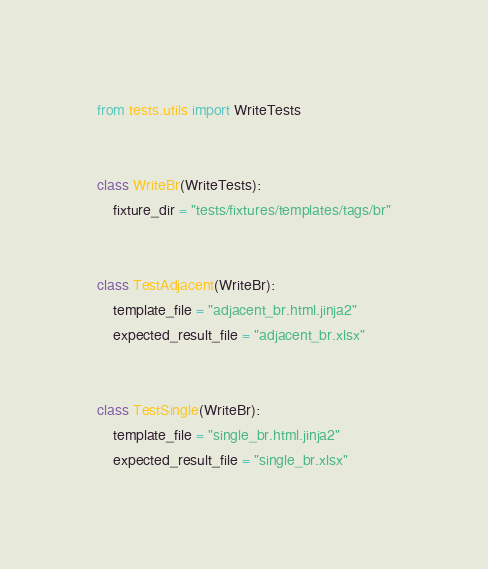<code> <loc_0><loc_0><loc_500><loc_500><_Python_>from tests.utils import WriteTests


class WriteBr(WriteTests):
    fixture_dir = "tests/fixtures/templates/tags/br"


class TestAdjacent(WriteBr):
    template_file = "adjacent_br.html.jinja2"
    expected_result_file = "adjacent_br.xlsx"


class TestSingle(WriteBr):
    template_file = "single_br.html.jinja2"
    expected_result_file = "single_br.xlsx"
</code> 